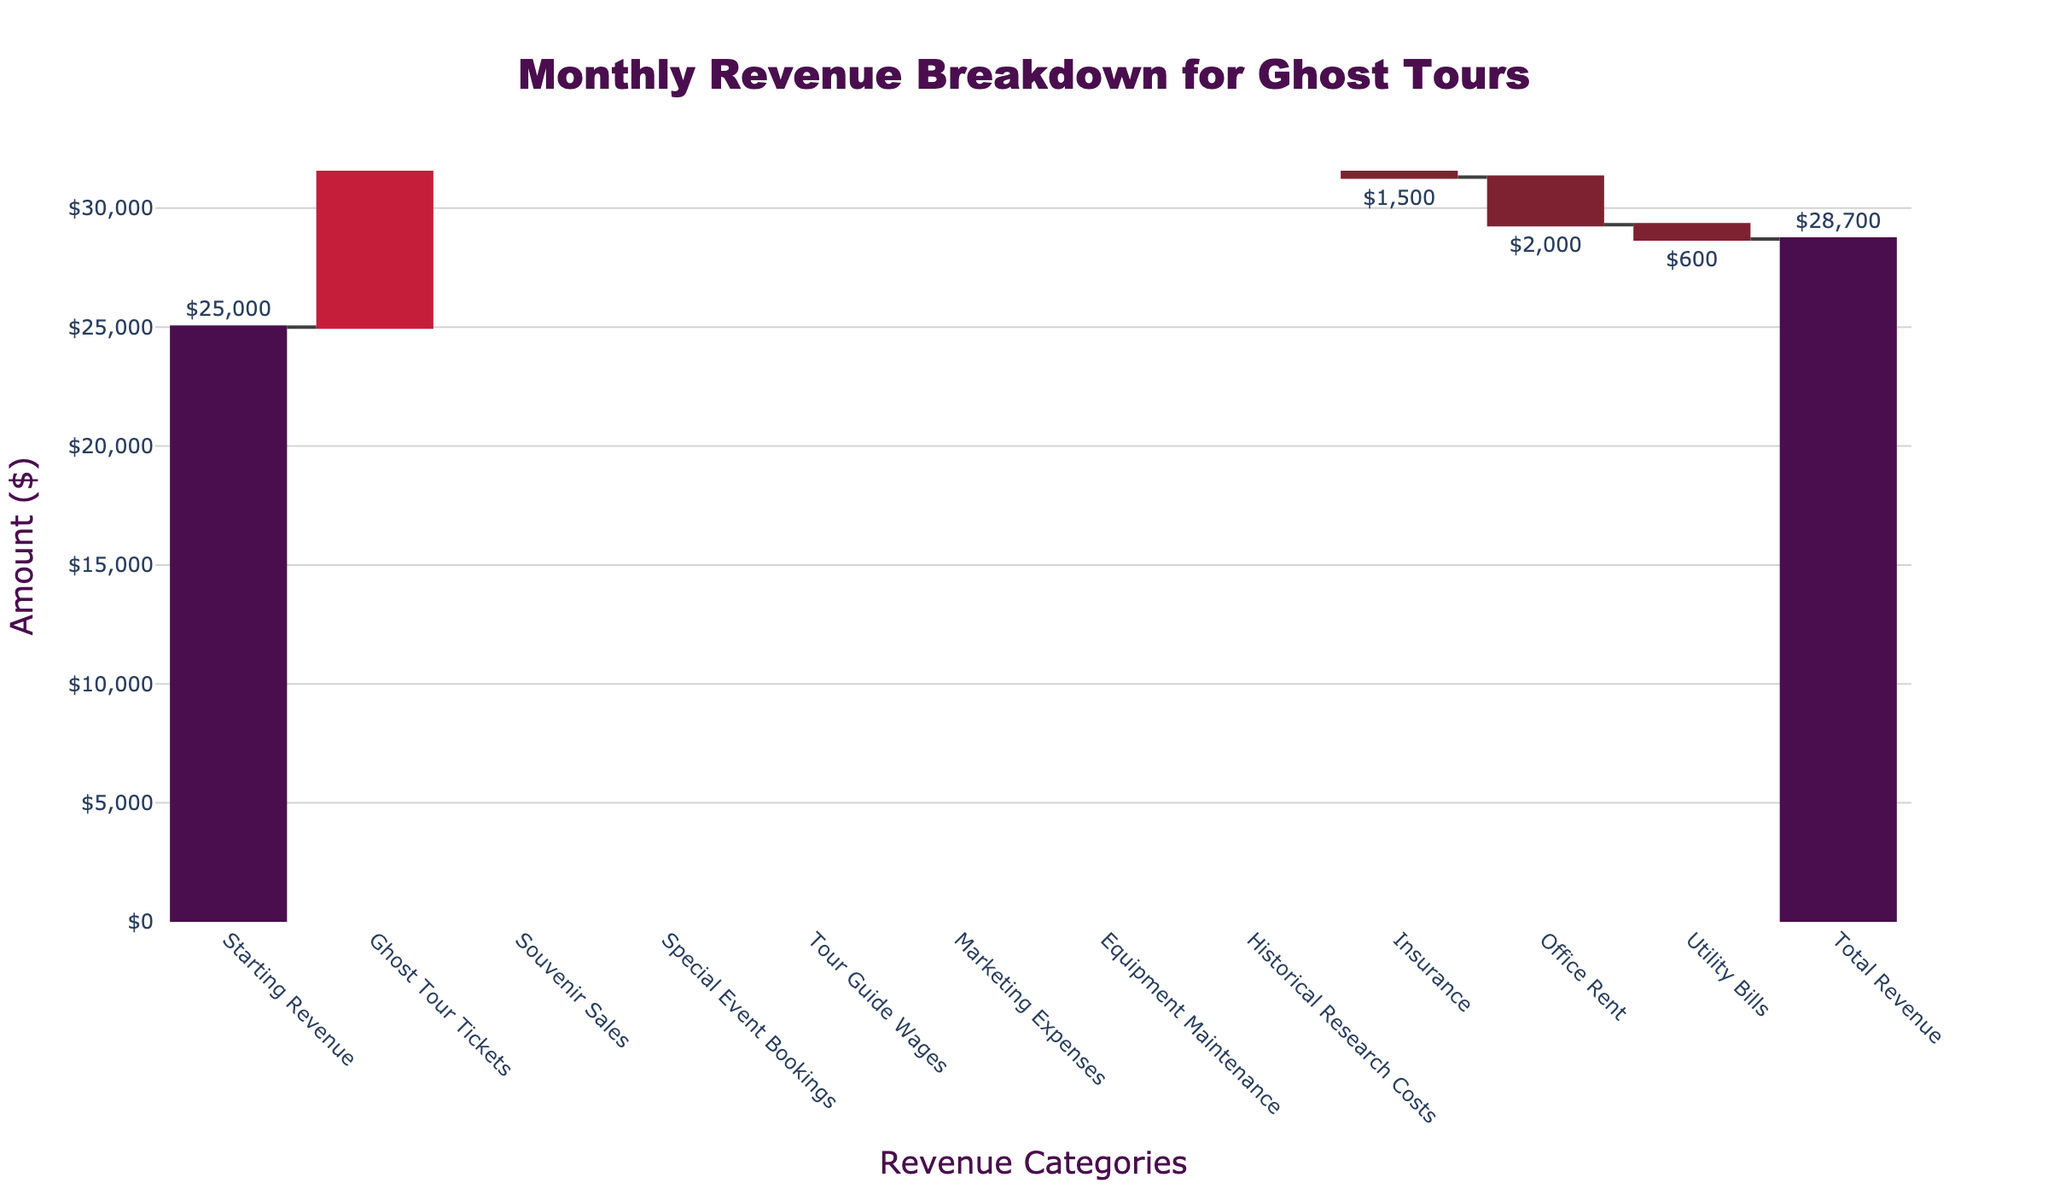What is the title of the chart? The title of the chart is usually displayed at the top and it summarizes the information being presented. In this case, the title reads "Monthly Revenue Breakdown for Ghost Tours" which indicates the chart's theme.
Answer: Monthly Revenue Breakdown for Ghost Tours How many income categories are shown in the chart? Income categories in the chart are indicated by positive values. Here, we have "Ghost Tour Tickets," "Souvenir Sales," and "Special Event Bookings" as the income sources.
Answer: 3 Which revenue category contributes the most to the total revenue? By visually inspecting the lengths of the bars, especially those with increasing markers (red color), "Ghost Tour Tickets" stands out as the longest/red bar indicating the highest contribution.
Answer: Ghost Tour Tickets What is the total amount spent on tour guide wages and marketing expenses? We need to sum the tour guide wages ($8,000) and marketing expenses ($3,500), represented by their respective bar lengths. The total is $8,000 + $3,500 = $11,500.
Answer: $11,500 Which expense category has the smallest negative impact on revenue? The smallest negative impact means the shortest bar with a decreasing marker (dark red color). Here, "Historical Research Costs" with -$800 shows the smallest decline.
Answer: Historical Research Costs How much is the net gain from souvenir sales and special event bookings combined? The combined net gain is found by summing up $3,500 from “Souvenir Sales” and $2,800 from “Special Event Bookings”. The total is $3,500 + $2,800 = $6,300.
Answer: $6,300 How much higher is the starting revenue compared to the total revenue? The difference between starting revenue ($25,000) and total revenue ($28,700) is calculated as $28,700 - $25,000 = $3,700.
Answer: $3,700 If you had to cut one expense to increase net revenue, which one would you cut based on this chart? Cutting the largest expense would have the greatest impact on increasing net revenue. "Tour Guide Wages" at $8,000 appears to be the largest single expense, so eliminating it would result in the largest net revenue increase.
Answer: Tour Guide Wages What visual element indicates the positive contribution of a category in the chart? The positive contributions are indicated by rising bars with an increasing marker (red color). These bars represent additional income or revenue categories.
Answer: Rising bars with red color 